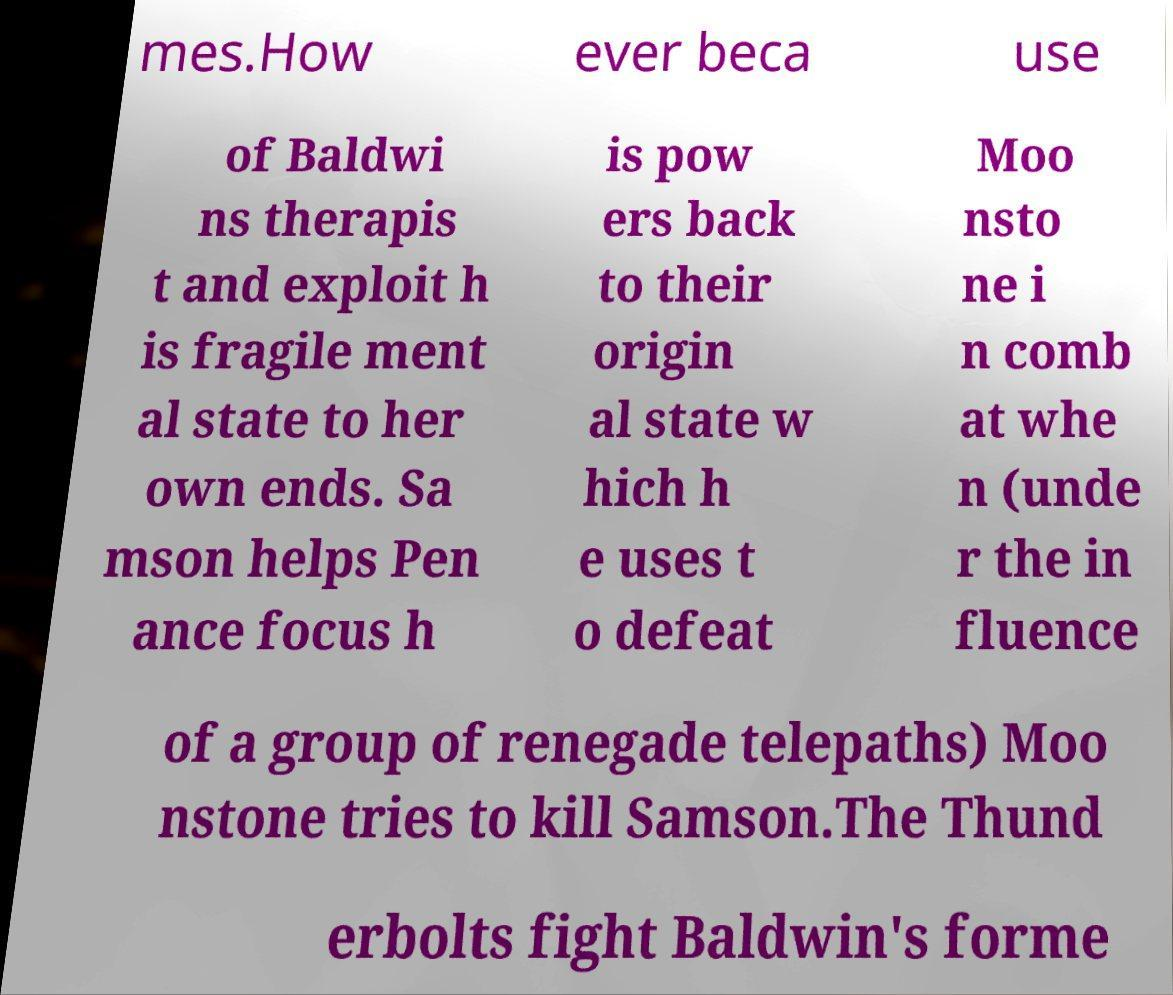Please identify and transcribe the text found in this image. mes.How ever beca use of Baldwi ns therapis t and exploit h is fragile ment al state to her own ends. Sa mson helps Pen ance focus h is pow ers back to their origin al state w hich h e uses t o defeat Moo nsto ne i n comb at whe n (unde r the in fluence of a group of renegade telepaths) Moo nstone tries to kill Samson.The Thund erbolts fight Baldwin's forme 